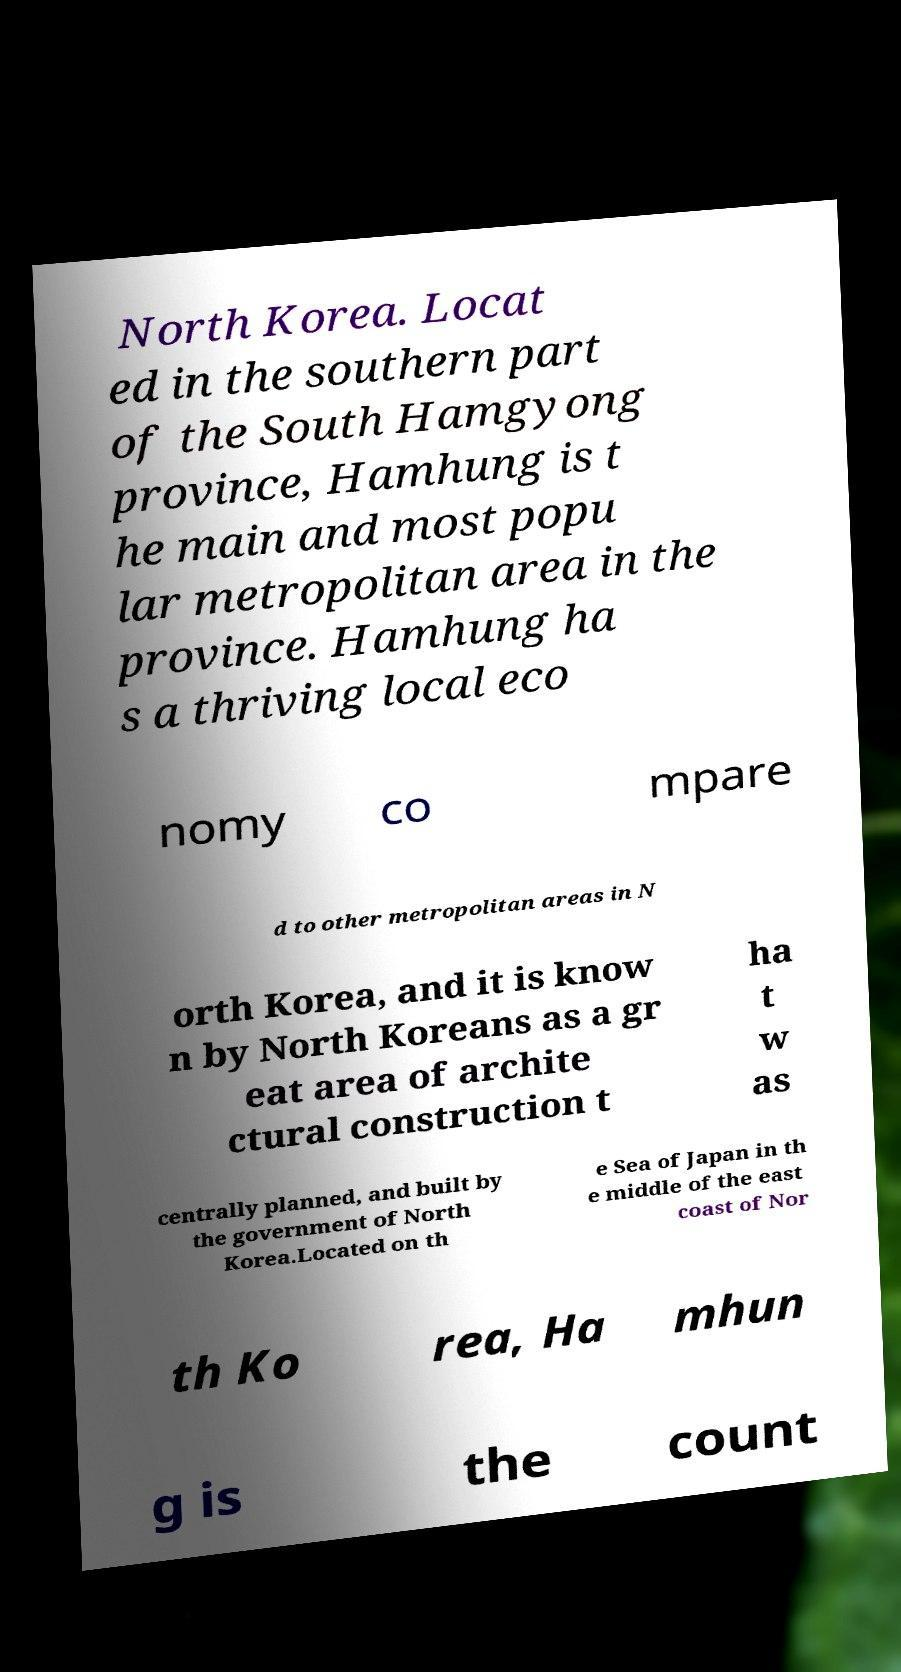Can you accurately transcribe the text from the provided image for me? North Korea. Locat ed in the southern part of the South Hamgyong province, Hamhung is t he main and most popu lar metropolitan area in the province. Hamhung ha s a thriving local eco nomy co mpare d to other metropolitan areas in N orth Korea, and it is know n by North Koreans as a gr eat area of archite ctural construction t ha t w as centrally planned, and built by the government of North Korea.Located on th e Sea of Japan in th e middle of the east coast of Nor th Ko rea, Ha mhun g is the count 